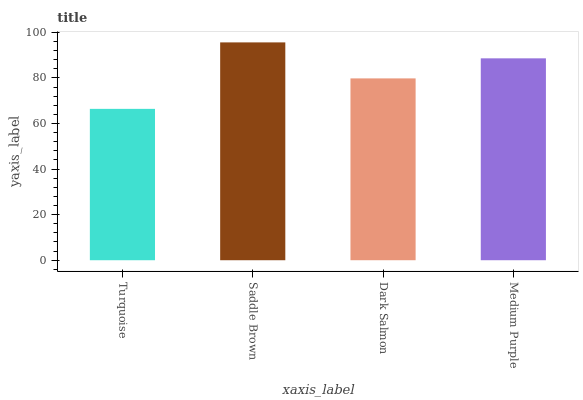Is Turquoise the minimum?
Answer yes or no. Yes. Is Saddle Brown the maximum?
Answer yes or no. Yes. Is Dark Salmon the minimum?
Answer yes or no. No. Is Dark Salmon the maximum?
Answer yes or no. No. Is Saddle Brown greater than Dark Salmon?
Answer yes or no. Yes. Is Dark Salmon less than Saddle Brown?
Answer yes or no. Yes. Is Dark Salmon greater than Saddle Brown?
Answer yes or no. No. Is Saddle Brown less than Dark Salmon?
Answer yes or no. No. Is Medium Purple the high median?
Answer yes or no. Yes. Is Dark Salmon the low median?
Answer yes or no. Yes. Is Dark Salmon the high median?
Answer yes or no. No. Is Turquoise the low median?
Answer yes or no. No. 